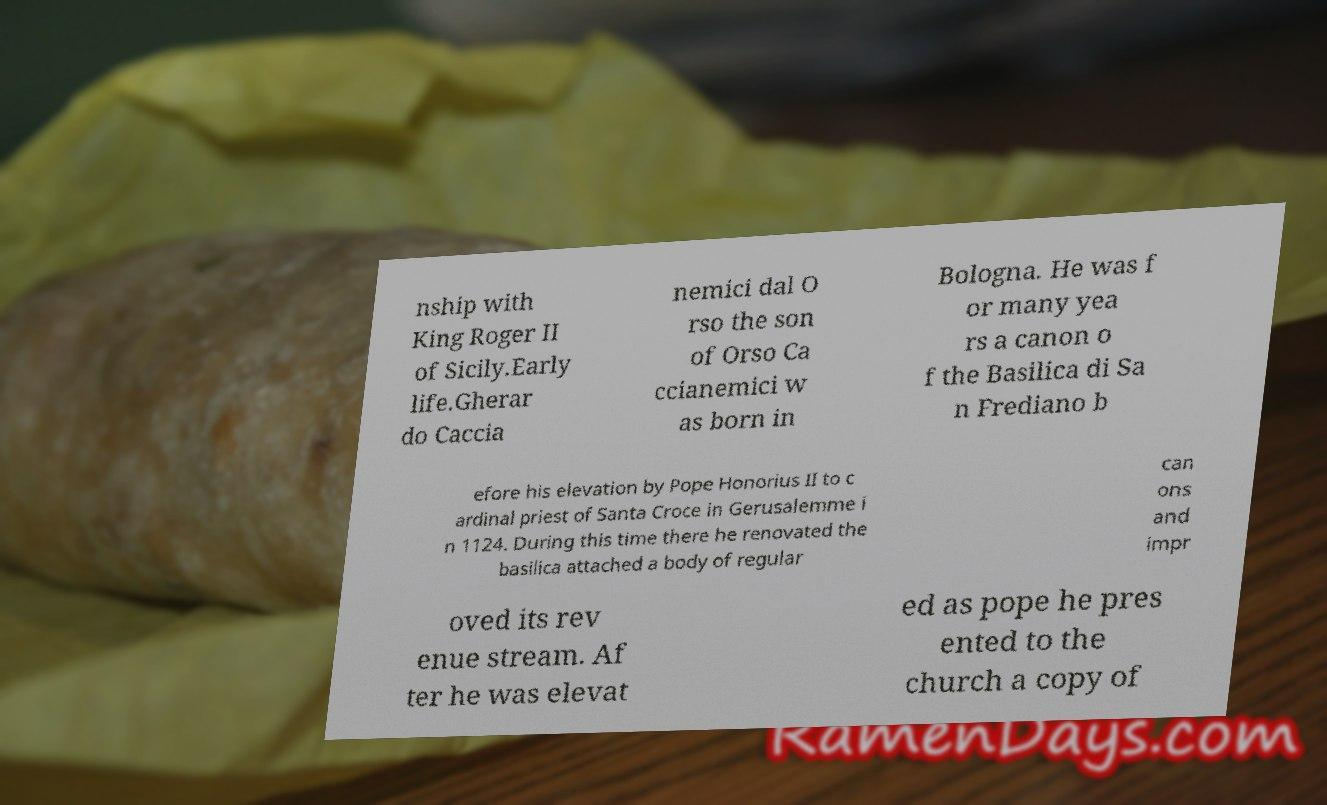Please identify and transcribe the text found in this image. nship with King Roger II of Sicily.Early life.Gherar do Caccia nemici dal O rso the son of Orso Ca ccianemici w as born in Bologna. He was f or many yea rs a canon o f the Basilica di Sa n Frediano b efore his elevation by Pope Honorius II to c ardinal priest of Santa Croce in Gerusalemme i n 1124. During this time there he renovated the basilica attached a body of regular can ons and impr oved its rev enue stream. Af ter he was elevat ed as pope he pres ented to the church a copy of 